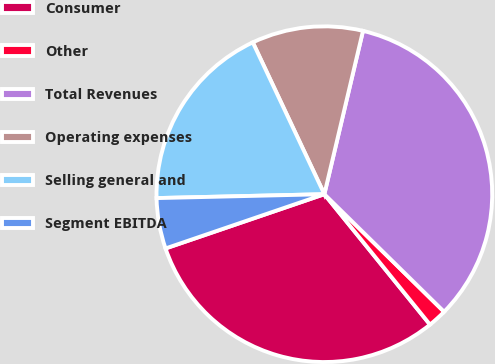Convert chart. <chart><loc_0><loc_0><loc_500><loc_500><pie_chart><fcel>Consumer<fcel>Other<fcel>Total Revenues<fcel>Operating expenses<fcel>Selling general and<fcel>Segment EBITDA<nl><fcel>30.6%<fcel>1.81%<fcel>33.66%<fcel>10.71%<fcel>18.36%<fcel>4.87%<nl></chart> 